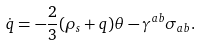Convert formula to latex. <formula><loc_0><loc_0><loc_500><loc_500>\dot { q } = - \frac { 2 } { 3 } ( \rho _ { s } + q ) \theta - \gamma ^ { a b } \sigma _ { a b } .</formula> 